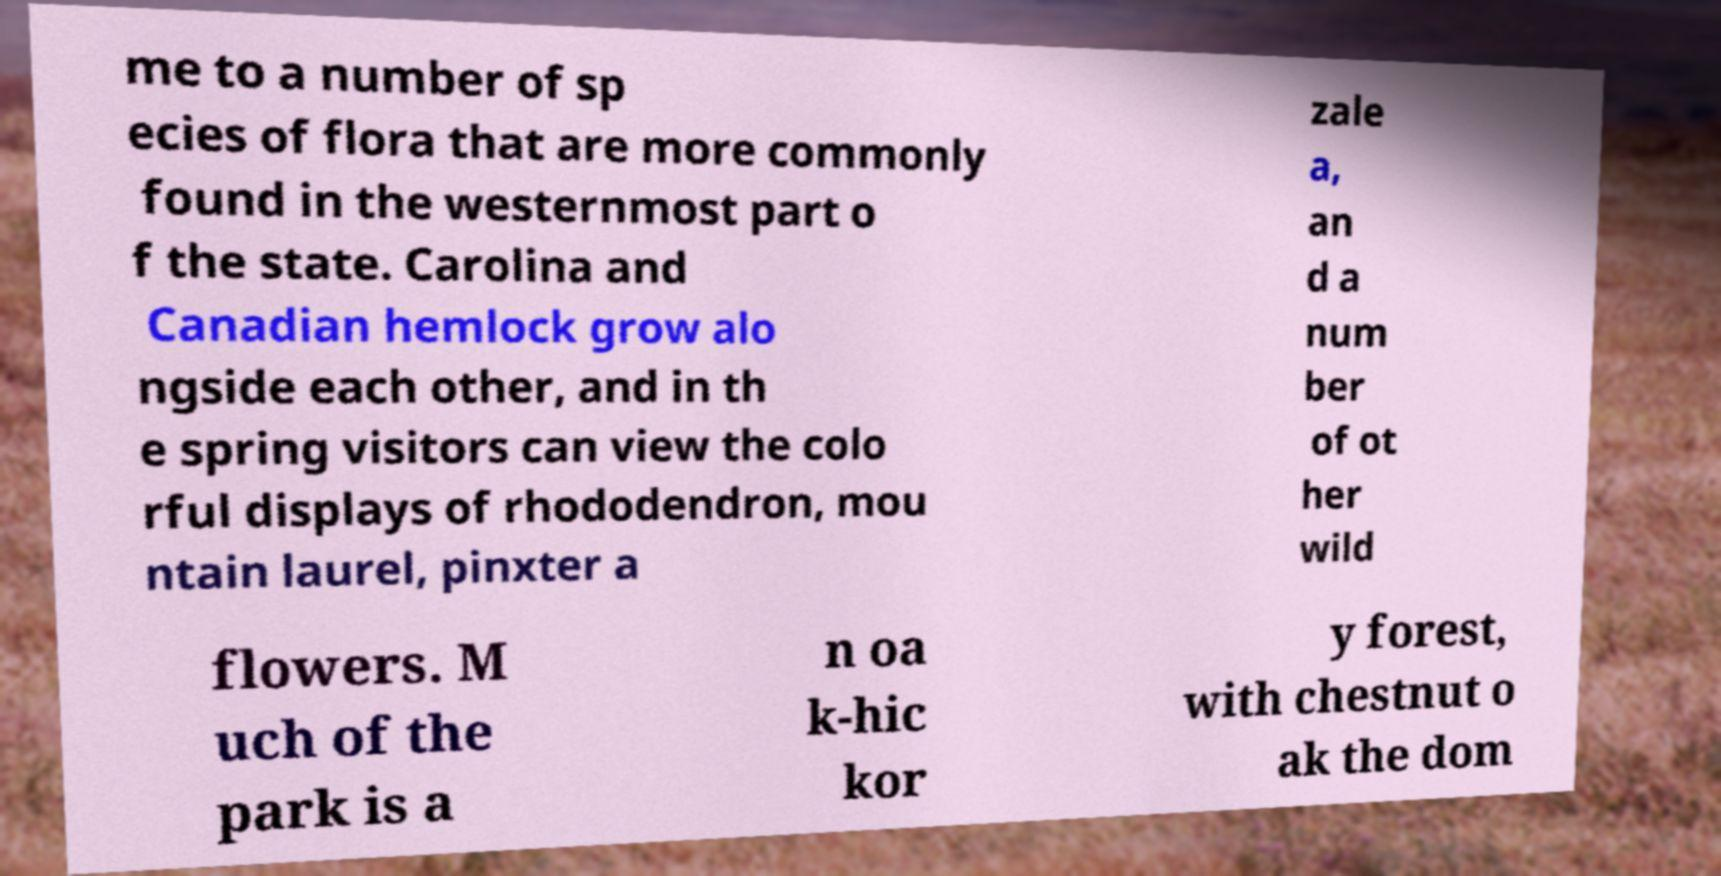Could you extract and type out the text from this image? me to a number of sp ecies of flora that are more commonly found in the westernmost part o f the state. Carolina and Canadian hemlock grow alo ngside each other, and in th e spring visitors can view the colo rful displays of rhododendron, mou ntain laurel, pinxter a zale a, an d a num ber of ot her wild flowers. M uch of the park is a n oa k-hic kor y forest, with chestnut o ak the dom 